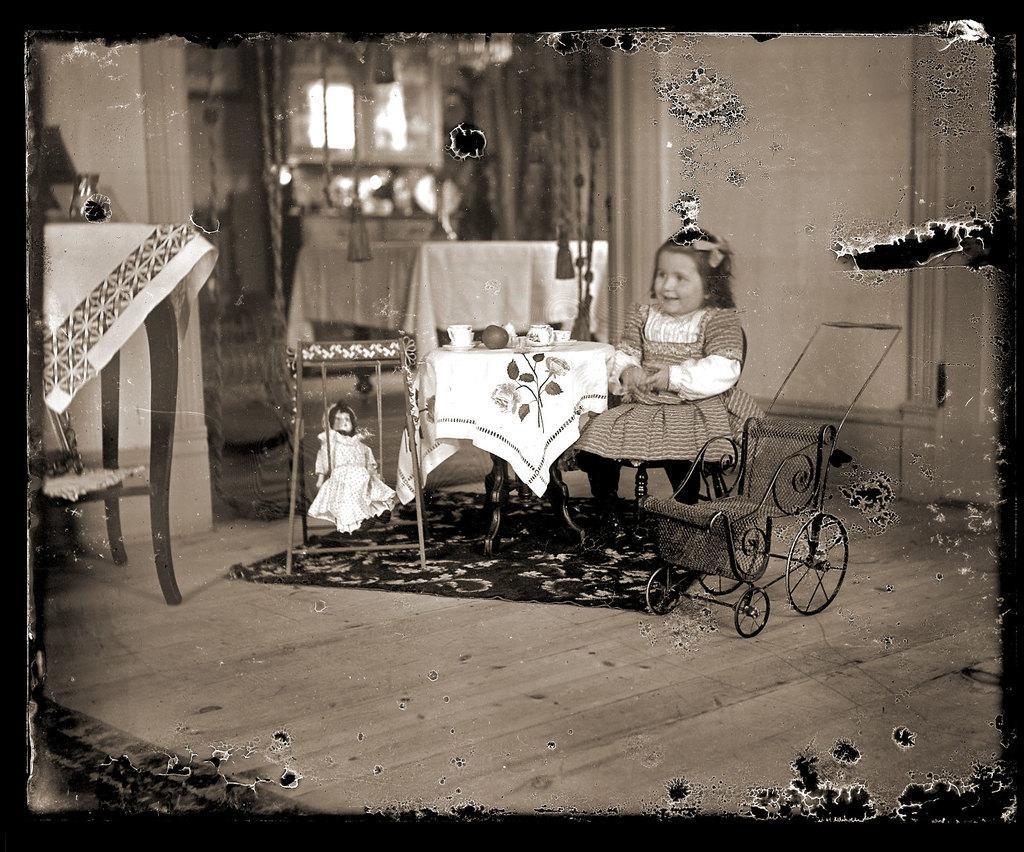How would you summarize this image in a sentence or two? in the center we can see one baby sitting on the chair around the table. On the table we can see some food items. In front of her we can see wheelchair. And coming to back we can see wall,table,lamp etc. 